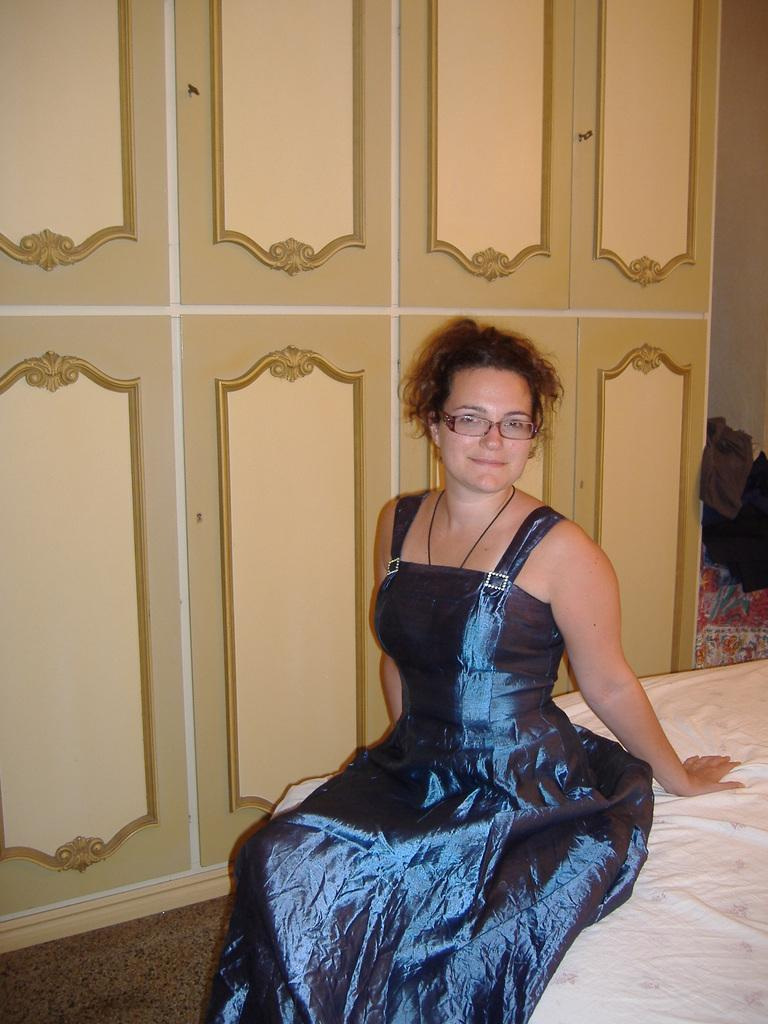Who is present in the image? There is a woman in the image. What is the woman wearing on her face? The woman is wearing spectacles. Where is the woman sitting? The woman is sitting on a bed. What is the woman's facial expression? The woman is smiling. What can be seen in the background of the image? There are cupboards and clothes in the background of the image. Can you tell me how many beggars are visible in the image? There are no beggars present in the image; it features a woman sitting on a bed. What type of sweater is the woman wearing in the image? The woman is not wearing a sweater in the image; she is wearing spectacles. 